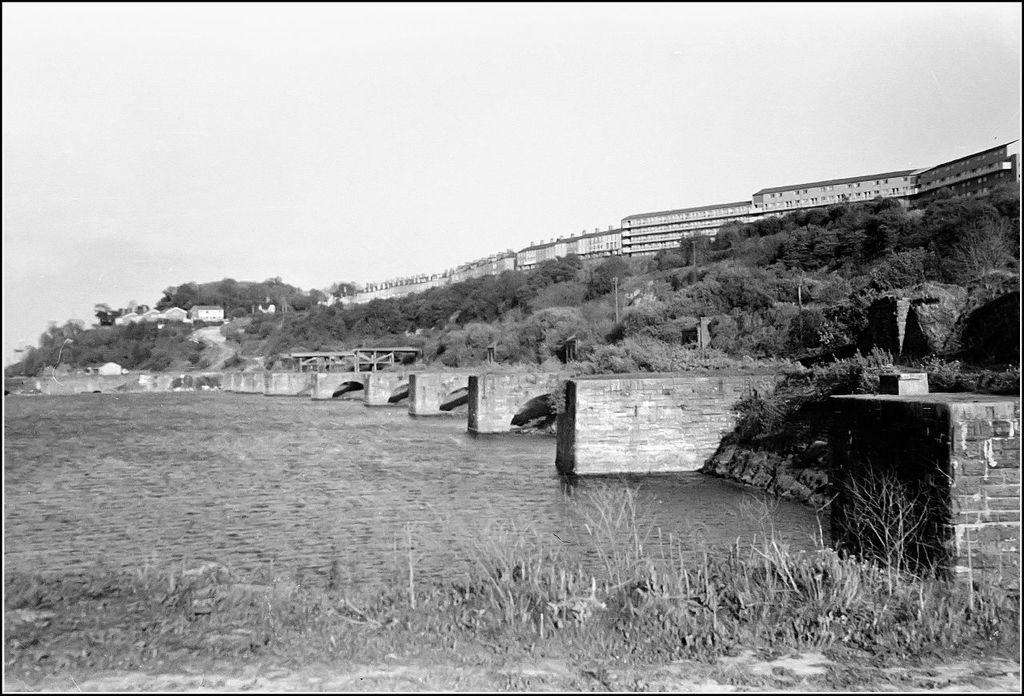What is the color scheme of the image? The image is black and white. What can be seen in the middle of the image? There are trees and buildings in the middle of the image. What is visible at the bottom of the image? There is water visible at the bottom of the image. What type of cheese is being used to build the society in the image? There is no cheese or society present in the image; it features trees, buildings, and water. How many rods can be seen supporting the buildings in the image? There are no rods visible in the image; the buildings appear to be supported by traditional construction methods. 